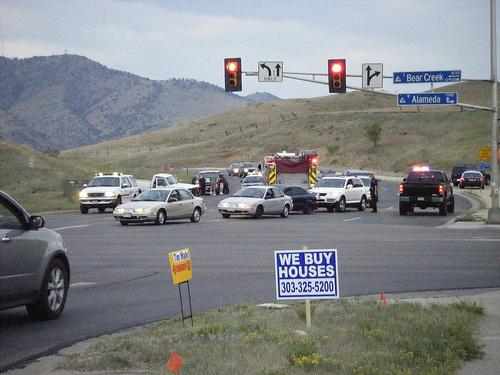Question: why are the cars stopped?
Choices:
A. Police stop.
B. Traffic.
C. Traffic light.
D. Accident.
Answer with the letter. Answer: C Question: what color is the traffic light?
Choices:
A. Blue.
B. Green.
C. Red.
D. Yellow.
Answer with the letter. Answer: C Question: what is the street made of?
Choices:
A. Concrete.
B. Dirt.
C. Stone.
D. Ashphalt.
Answer with the letter. Answer: D Question: how many blue and white signs are there?
Choices:
A. 5.
B. 6.
C. 7.
D. 1.
Answer with the letter. Answer: D Question: what is the landscape?
Choices:
A. Mountains.
B. Field.
C. Flowers.
D. Hills.
Answer with the letter. Answer: D 